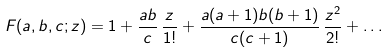Convert formula to latex. <formula><loc_0><loc_0><loc_500><loc_500>F ( a , b , c ; z ) = 1 + \frac { a b } { c } \, \frac { z } { 1 ! } + \frac { a ( a + 1 ) b ( b + 1 ) } { c ( c + 1 ) } \, \frac { z ^ { 2 } } { 2 ! } + \dots</formula> 